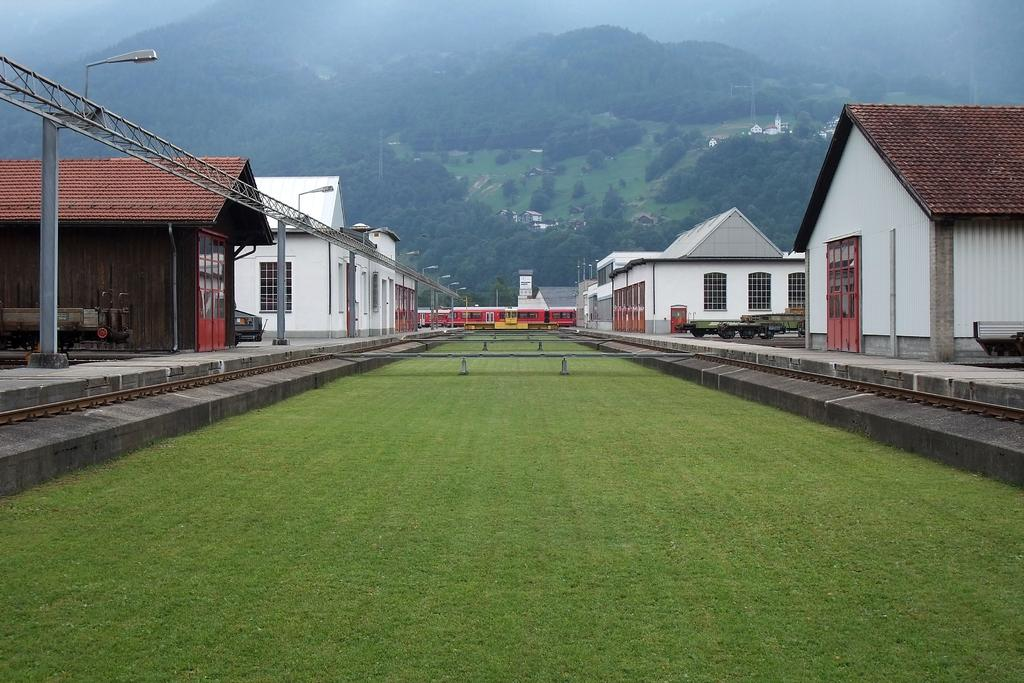What is the main subject of the image? The main subject of the image is a train. What type of structures can be seen in the image? There are houses in the image. What architectural element is present in the image? There is a beam in the image. What type of vertical structures are in the image? There are poles in the image. What type of illumination is present in the image? There are lights in the image. What type of natural vegetation is visible in the image? There is grass in the image. What type of larger vegetation is visible in the image? There are trees in the image. Are there any other objects present in the image? Yes, there are other objects in the image. How many cans of soda are visible in the image? There are no cans of soda present in the image. Are there any dogs visible in the image? There are no dogs present in the image. 